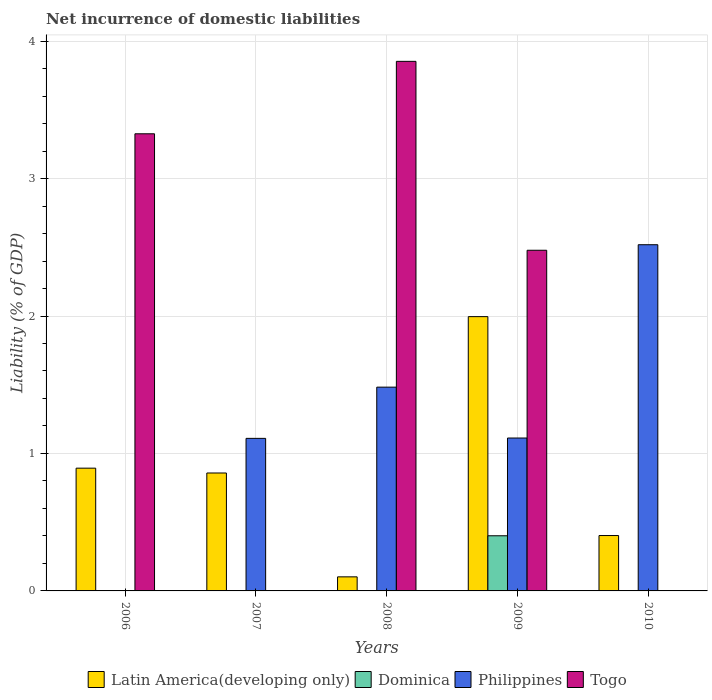Are the number of bars per tick equal to the number of legend labels?
Offer a terse response. No. How many bars are there on the 2nd tick from the right?
Offer a terse response. 4. What is the label of the 5th group of bars from the left?
Your answer should be very brief. 2010. What is the net incurrence of domestic liabilities in Togo in 2009?
Ensure brevity in your answer.  2.48. Across all years, what is the maximum net incurrence of domestic liabilities in Latin America(developing only)?
Give a very brief answer. 2. In which year was the net incurrence of domestic liabilities in Dominica maximum?
Give a very brief answer. 2009. What is the total net incurrence of domestic liabilities in Philippines in the graph?
Offer a terse response. 6.22. What is the difference between the net incurrence of domestic liabilities in Togo in 2006 and that in 2008?
Keep it short and to the point. -0.53. What is the difference between the net incurrence of domestic liabilities in Dominica in 2008 and the net incurrence of domestic liabilities in Togo in 2006?
Provide a short and direct response. -3.33. What is the average net incurrence of domestic liabilities in Philippines per year?
Your answer should be compact. 1.24. In the year 2009, what is the difference between the net incurrence of domestic liabilities in Togo and net incurrence of domestic liabilities in Dominica?
Your response must be concise. 2.08. What is the ratio of the net incurrence of domestic liabilities in Latin America(developing only) in 2008 to that in 2009?
Your answer should be very brief. 0.05. Is the net incurrence of domestic liabilities in Latin America(developing only) in 2008 less than that in 2009?
Your answer should be compact. Yes. What is the difference between the highest and the second highest net incurrence of domestic liabilities in Philippines?
Keep it short and to the point. 1.04. What is the difference between the highest and the lowest net incurrence of domestic liabilities in Philippines?
Your response must be concise. 2.52. Are all the bars in the graph horizontal?
Make the answer very short. No. What is the difference between two consecutive major ticks on the Y-axis?
Give a very brief answer. 1. Are the values on the major ticks of Y-axis written in scientific E-notation?
Make the answer very short. No. Does the graph contain any zero values?
Your answer should be compact. Yes. Where does the legend appear in the graph?
Give a very brief answer. Bottom center. How are the legend labels stacked?
Offer a very short reply. Horizontal. What is the title of the graph?
Keep it short and to the point. Net incurrence of domestic liabilities. What is the label or title of the Y-axis?
Provide a succinct answer. Liability (% of GDP). What is the Liability (% of GDP) of Latin America(developing only) in 2006?
Provide a short and direct response. 0.89. What is the Liability (% of GDP) in Togo in 2006?
Offer a very short reply. 3.33. What is the Liability (% of GDP) in Latin America(developing only) in 2007?
Make the answer very short. 0.86. What is the Liability (% of GDP) of Philippines in 2007?
Offer a terse response. 1.11. What is the Liability (% of GDP) of Togo in 2007?
Make the answer very short. 0. What is the Liability (% of GDP) of Latin America(developing only) in 2008?
Offer a terse response. 0.1. What is the Liability (% of GDP) of Dominica in 2008?
Offer a very short reply. 0. What is the Liability (% of GDP) of Philippines in 2008?
Make the answer very short. 1.48. What is the Liability (% of GDP) of Togo in 2008?
Your answer should be compact. 3.85. What is the Liability (% of GDP) of Latin America(developing only) in 2009?
Offer a terse response. 2. What is the Liability (% of GDP) of Dominica in 2009?
Offer a terse response. 0.4. What is the Liability (% of GDP) in Philippines in 2009?
Offer a terse response. 1.11. What is the Liability (% of GDP) in Togo in 2009?
Your response must be concise. 2.48. What is the Liability (% of GDP) of Latin America(developing only) in 2010?
Your answer should be very brief. 0.4. What is the Liability (% of GDP) in Dominica in 2010?
Your answer should be compact. 0. What is the Liability (% of GDP) of Philippines in 2010?
Your answer should be compact. 2.52. Across all years, what is the maximum Liability (% of GDP) in Latin America(developing only)?
Offer a terse response. 2. Across all years, what is the maximum Liability (% of GDP) of Dominica?
Ensure brevity in your answer.  0.4. Across all years, what is the maximum Liability (% of GDP) of Philippines?
Provide a short and direct response. 2.52. Across all years, what is the maximum Liability (% of GDP) of Togo?
Offer a terse response. 3.85. Across all years, what is the minimum Liability (% of GDP) in Latin America(developing only)?
Offer a terse response. 0.1. Across all years, what is the minimum Liability (% of GDP) in Philippines?
Give a very brief answer. 0. Across all years, what is the minimum Liability (% of GDP) in Togo?
Your response must be concise. 0. What is the total Liability (% of GDP) of Latin America(developing only) in the graph?
Give a very brief answer. 4.25. What is the total Liability (% of GDP) of Dominica in the graph?
Ensure brevity in your answer.  0.4. What is the total Liability (% of GDP) in Philippines in the graph?
Your answer should be very brief. 6.22. What is the total Liability (% of GDP) of Togo in the graph?
Offer a very short reply. 9.66. What is the difference between the Liability (% of GDP) of Latin America(developing only) in 2006 and that in 2007?
Provide a short and direct response. 0.04. What is the difference between the Liability (% of GDP) of Latin America(developing only) in 2006 and that in 2008?
Keep it short and to the point. 0.79. What is the difference between the Liability (% of GDP) in Togo in 2006 and that in 2008?
Your answer should be compact. -0.53. What is the difference between the Liability (% of GDP) in Latin America(developing only) in 2006 and that in 2009?
Your answer should be very brief. -1.1. What is the difference between the Liability (% of GDP) of Togo in 2006 and that in 2009?
Keep it short and to the point. 0.85. What is the difference between the Liability (% of GDP) in Latin America(developing only) in 2006 and that in 2010?
Your response must be concise. 0.49. What is the difference between the Liability (% of GDP) in Latin America(developing only) in 2007 and that in 2008?
Provide a short and direct response. 0.76. What is the difference between the Liability (% of GDP) in Philippines in 2007 and that in 2008?
Provide a succinct answer. -0.37. What is the difference between the Liability (% of GDP) of Latin America(developing only) in 2007 and that in 2009?
Your answer should be compact. -1.14. What is the difference between the Liability (% of GDP) of Philippines in 2007 and that in 2009?
Provide a short and direct response. -0. What is the difference between the Liability (% of GDP) in Latin America(developing only) in 2007 and that in 2010?
Provide a succinct answer. 0.46. What is the difference between the Liability (% of GDP) of Philippines in 2007 and that in 2010?
Provide a succinct answer. -1.41. What is the difference between the Liability (% of GDP) of Latin America(developing only) in 2008 and that in 2009?
Give a very brief answer. -1.89. What is the difference between the Liability (% of GDP) in Philippines in 2008 and that in 2009?
Offer a very short reply. 0.37. What is the difference between the Liability (% of GDP) of Togo in 2008 and that in 2009?
Your response must be concise. 1.37. What is the difference between the Liability (% of GDP) of Latin America(developing only) in 2008 and that in 2010?
Ensure brevity in your answer.  -0.3. What is the difference between the Liability (% of GDP) in Philippines in 2008 and that in 2010?
Offer a very short reply. -1.04. What is the difference between the Liability (% of GDP) in Latin America(developing only) in 2009 and that in 2010?
Your answer should be compact. 1.59. What is the difference between the Liability (% of GDP) of Philippines in 2009 and that in 2010?
Keep it short and to the point. -1.41. What is the difference between the Liability (% of GDP) of Latin America(developing only) in 2006 and the Liability (% of GDP) of Philippines in 2007?
Your response must be concise. -0.22. What is the difference between the Liability (% of GDP) in Latin America(developing only) in 2006 and the Liability (% of GDP) in Philippines in 2008?
Provide a short and direct response. -0.59. What is the difference between the Liability (% of GDP) in Latin America(developing only) in 2006 and the Liability (% of GDP) in Togo in 2008?
Your response must be concise. -2.96. What is the difference between the Liability (% of GDP) of Latin America(developing only) in 2006 and the Liability (% of GDP) of Dominica in 2009?
Give a very brief answer. 0.49. What is the difference between the Liability (% of GDP) of Latin America(developing only) in 2006 and the Liability (% of GDP) of Philippines in 2009?
Give a very brief answer. -0.22. What is the difference between the Liability (% of GDP) in Latin America(developing only) in 2006 and the Liability (% of GDP) in Togo in 2009?
Provide a succinct answer. -1.59. What is the difference between the Liability (% of GDP) of Latin America(developing only) in 2006 and the Liability (% of GDP) of Philippines in 2010?
Offer a terse response. -1.63. What is the difference between the Liability (% of GDP) in Latin America(developing only) in 2007 and the Liability (% of GDP) in Philippines in 2008?
Give a very brief answer. -0.62. What is the difference between the Liability (% of GDP) in Latin America(developing only) in 2007 and the Liability (% of GDP) in Togo in 2008?
Offer a very short reply. -2.99. What is the difference between the Liability (% of GDP) of Philippines in 2007 and the Liability (% of GDP) of Togo in 2008?
Your response must be concise. -2.74. What is the difference between the Liability (% of GDP) of Latin America(developing only) in 2007 and the Liability (% of GDP) of Dominica in 2009?
Your answer should be compact. 0.46. What is the difference between the Liability (% of GDP) in Latin America(developing only) in 2007 and the Liability (% of GDP) in Philippines in 2009?
Offer a very short reply. -0.25. What is the difference between the Liability (% of GDP) in Latin America(developing only) in 2007 and the Liability (% of GDP) in Togo in 2009?
Ensure brevity in your answer.  -1.62. What is the difference between the Liability (% of GDP) in Philippines in 2007 and the Liability (% of GDP) in Togo in 2009?
Provide a succinct answer. -1.37. What is the difference between the Liability (% of GDP) of Latin America(developing only) in 2007 and the Liability (% of GDP) of Philippines in 2010?
Ensure brevity in your answer.  -1.66. What is the difference between the Liability (% of GDP) of Latin America(developing only) in 2008 and the Liability (% of GDP) of Dominica in 2009?
Give a very brief answer. -0.3. What is the difference between the Liability (% of GDP) in Latin America(developing only) in 2008 and the Liability (% of GDP) in Philippines in 2009?
Provide a succinct answer. -1.01. What is the difference between the Liability (% of GDP) of Latin America(developing only) in 2008 and the Liability (% of GDP) of Togo in 2009?
Ensure brevity in your answer.  -2.38. What is the difference between the Liability (% of GDP) in Philippines in 2008 and the Liability (% of GDP) in Togo in 2009?
Give a very brief answer. -1. What is the difference between the Liability (% of GDP) of Latin America(developing only) in 2008 and the Liability (% of GDP) of Philippines in 2010?
Offer a terse response. -2.42. What is the difference between the Liability (% of GDP) of Latin America(developing only) in 2009 and the Liability (% of GDP) of Philippines in 2010?
Your answer should be very brief. -0.52. What is the difference between the Liability (% of GDP) of Dominica in 2009 and the Liability (% of GDP) of Philippines in 2010?
Your response must be concise. -2.12. What is the average Liability (% of GDP) of Latin America(developing only) per year?
Offer a very short reply. 0.85. What is the average Liability (% of GDP) in Dominica per year?
Ensure brevity in your answer.  0.08. What is the average Liability (% of GDP) in Philippines per year?
Your answer should be very brief. 1.24. What is the average Liability (% of GDP) in Togo per year?
Provide a succinct answer. 1.93. In the year 2006, what is the difference between the Liability (% of GDP) in Latin America(developing only) and Liability (% of GDP) in Togo?
Your response must be concise. -2.43. In the year 2007, what is the difference between the Liability (% of GDP) of Latin America(developing only) and Liability (% of GDP) of Philippines?
Provide a succinct answer. -0.25. In the year 2008, what is the difference between the Liability (% of GDP) of Latin America(developing only) and Liability (% of GDP) of Philippines?
Make the answer very short. -1.38. In the year 2008, what is the difference between the Liability (% of GDP) of Latin America(developing only) and Liability (% of GDP) of Togo?
Provide a succinct answer. -3.75. In the year 2008, what is the difference between the Liability (% of GDP) of Philippines and Liability (% of GDP) of Togo?
Give a very brief answer. -2.37. In the year 2009, what is the difference between the Liability (% of GDP) of Latin America(developing only) and Liability (% of GDP) of Dominica?
Provide a short and direct response. 1.59. In the year 2009, what is the difference between the Liability (% of GDP) in Latin America(developing only) and Liability (% of GDP) in Philippines?
Your response must be concise. 0.88. In the year 2009, what is the difference between the Liability (% of GDP) in Latin America(developing only) and Liability (% of GDP) in Togo?
Provide a succinct answer. -0.48. In the year 2009, what is the difference between the Liability (% of GDP) in Dominica and Liability (% of GDP) in Philippines?
Your response must be concise. -0.71. In the year 2009, what is the difference between the Liability (% of GDP) of Dominica and Liability (% of GDP) of Togo?
Offer a terse response. -2.08. In the year 2009, what is the difference between the Liability (% of GDP) in Philippines and Liability (% of GDP) in Togo?
Offer a terse response. -1.37. In the year 2010, what is the difference between the Liability (% of GDP) of Latin America(developing only) and Liability (% of GDP) of Philippines?
Keep it short and to the point. -2.12. What is the ratio of the Liability (% of GDP) of Latin America(developing only) in 2006 to that in 2007?
Give a very brief answer. 1.04. What is the ratio of the Liability (% of GDP) of Latin America(developing only) in 2006 to that in 2008?
Your response must be concise. 8.72. What is the ratio of the Liability (% of GDP) of Togo in 2006 to that in 2008?
Provide a short and direct response. 0.86. What is the ratio of the Liability (% of GDP) in Latin America(developing only) in 2006 to that in 2009?
Provide a short and direct response. 0.45. What is the ratio of the Liability (% of GDP) in Togo in 2006 to that in 2009?
Provide a short and direct response. 1.34. What is the ratio of the Liability (% of GDP) of Latin America(developing only) in 2006 to that in 2010?
Provide a succinct answer. 2.22. What is the ratio of the Liability (% of GDP) of Latin America(developing only) in 2007 to that in 2008?
Offer a terse response. 8.38. What is the ratio of the Liability (% of GDP) in Philippines in 2007 to that in 2008?
Give a very brief answer. 0.75. What is the ratio of the Liability (% of GDP) in Latin America(developing only) in 2007 to that in 2009?
Give a very brief answer. 0.43. What is the ratio of the Liability (% of GDP) of Latin America(developing only) in 2007 to that in 2010?
Offer a terse response. 2.13. What is the ratio of the Liability (% of GDP) of Philippines in 2007 to that in 2010?
Offer a very short reply. 0.44. What is the ratio of the Liability (% of GDP) of Latin America(developing only) in 2008 to that in 2009?
Provide a succinct answer. 0.05. What is the ratio of the Liability (% of GDP) in Philippines in 2008 to that in 2009?
Your answer should be very brief. 1.33. What is the ratio of the Liability (% of GDP) of Togo in 2008 to that in 2009?
Offer a very short reply. 1.55. What is the ratio of the Liability (% of GDP) of Latin America(developing only) in 2008 to that in 2010?
Give a very brief answer. 0.25. What is the ratio of the Liability (% of GDP) in Philippines in 2008 to that in 2010?
Make the answer very short. 0.59. What is the ratio of the Liability (% of GDP) in Latin America(developing only) in 2009 to that in 2010?
Make the answer very short. 4.95. What is the ratio of the Liability (% of GDP) in Philippines in 2009 to that in 2010?
Your answer should be compact. 0.44. What is the difference between the highest and the second highest Liability (% of GDP) in Latin America(developing only)?
Your response must be concise. 1.1. What is the difference between the highest and the second highest Liability (% of GDP) of Philippines?
Give a very brief answer. 1.04. What is the difference between the highest and the second highest Liability (% of GDP) of Togo?
Give a very brief answer. 0.53. What is the difference between the highest and the lowest Liability (% of GDP) of Latin America(developing only)?
Your response must be concise. 1.89. What is the difference between the highest and the lowest Liability (% of GDP) of Dominica?
Make the answer very short. 0.4. What is the difference between the highest and the lowest Liability (% of GDP) of Philippines?
Your response must be concise. 2.52. What is the difference between the highest and the lowest Liability (% of GDP) of Togo?
Your answer should be compact. 3.85. 